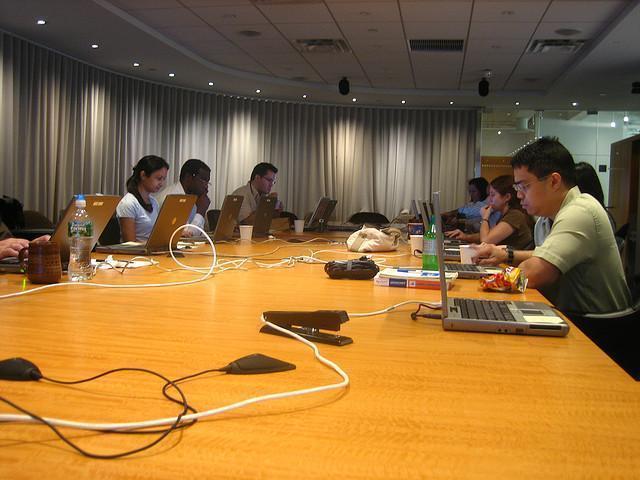Where are the people in?
Select the accurate response from the four choices given to answer the question.
Options: Cafeteria, theater, library, conference room. Conference room. 